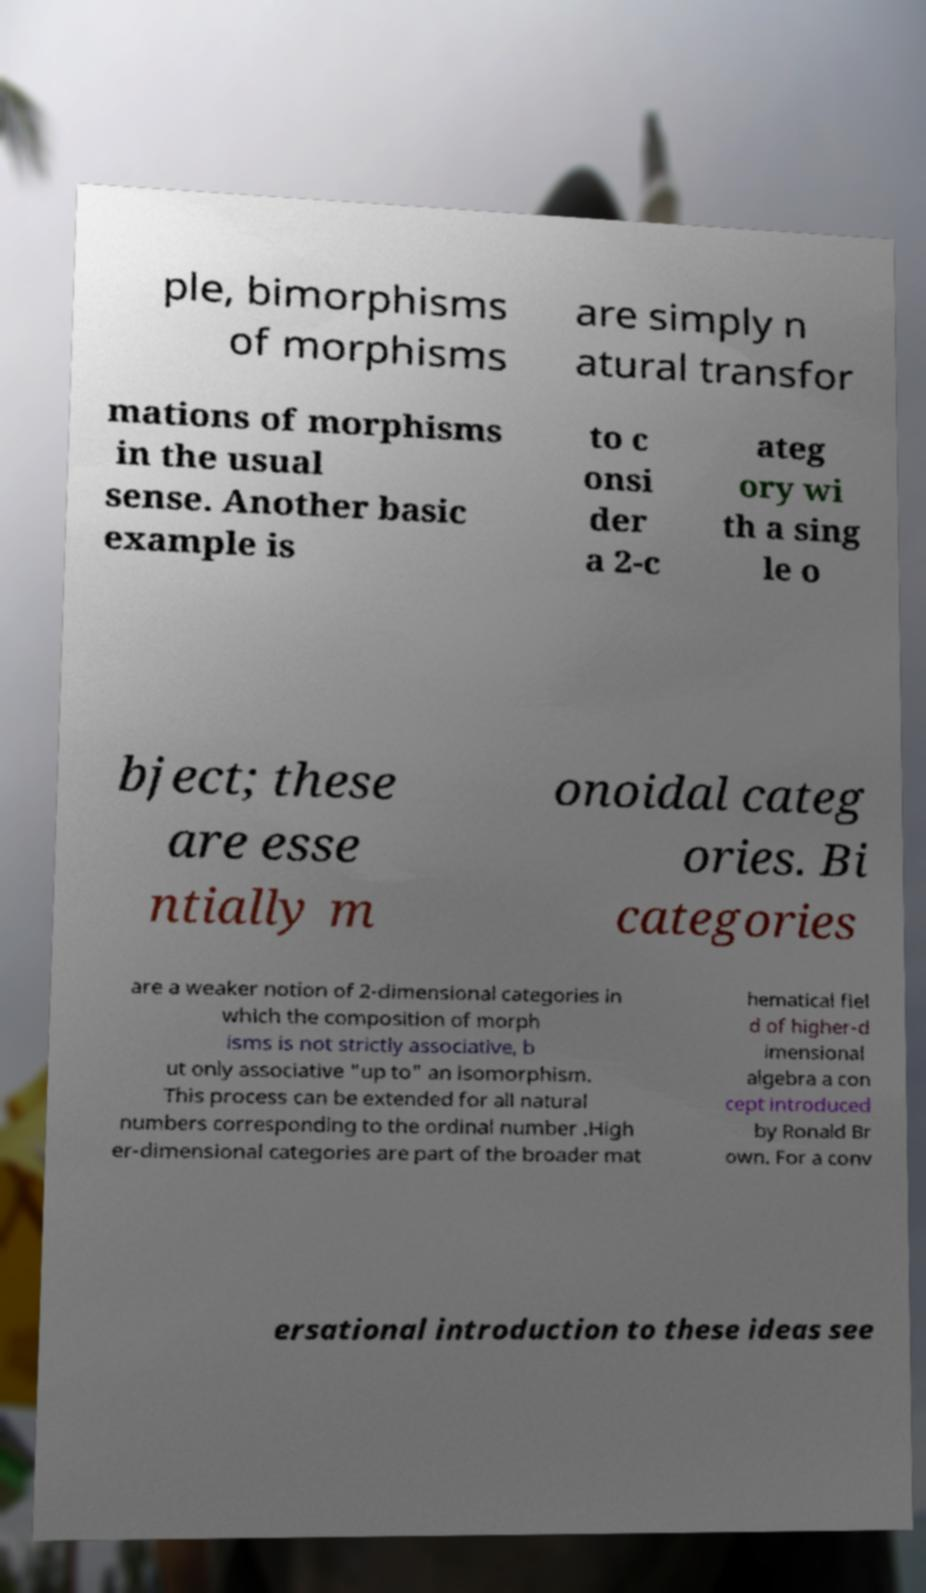Could you assist in decoding the text presented in this image and type it out clearly? ple, bimorphisms of morphisms are simply n atural transfor mations of morphisms in the usual sense. Another basic example is to c onsi der a 2-c ateg ory wi th a sing le o bject; these are esse ntially m onoidal categ ories. Bi categories are a weaker notion of 2-dimensional categories in which the composition of morph isms is not strictly associative, b ut only associative "up to" an isomorphism. This process can be extended for all natural numbers corresponding to the ordinal number .High er-dimensional categories are part of the broader mat hematical fiel d of higher-d imensional algebra a con cept introduced by Ronald Br own. For a conv ersational introduction to these ideas see 